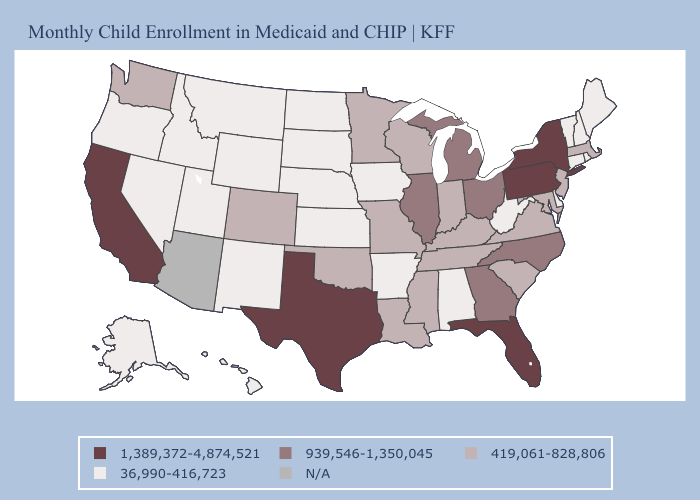Name the states that have a value in the range N/A?
Write a very short answer. Arizona. Does the first symbol in the legend represent the smallest category?
Keep it brief. No. Name the states that have a value in the range 36,990-416,723?
Concise answer only. Alabama, Alaska, Arkansas, Connecticut, Delaware, Hawaii, Idaho, Iowa, Kansas, Maine, Montana, Nebraska, Nevada, New Hampshire, New Mexico, North Dakota, Oregon, Rhode Island, South Dakota, Utah, Vermont, West Virginia, Wyoming. Name the states that have a value in the range 36,990-416,723?
Quick response, please. Alabama, Alaska, Arkansas, Connecticut, Delaware, Hawaii, Idaho, Iowa, Kansas, Maine, Montana, Nebraska, Nevada, New Hampshire, New Mexico, North Dakota, Oregon, Rhode Island, South Dakota, Utah, Vermont, West Virginia, Wyoming. What is the lowest value in states that border Tennessee?
Answer briefly. 36,990-416,723. Name the states that have a value in the range N/A?
Answer briefly. Arizona. What is the value of Kentucky?
Write a very short answer. 419,061-828,806. Which states hav the highest value in the Northeast?
Short answer required. New York, Pennsylvania. Is the legend a continuous bar?
Answer briefly. No. Name the states that have a value in the range 939,546-1,350,045?
Be succinct. Georgia, Illinois, Michigan, North Carolina, Ohio. Does Massachusetts have the lowest value in the Northeast?
Keep it brief. No. What is the value of Idaho?
Short answer required. 36,990-416,723. 